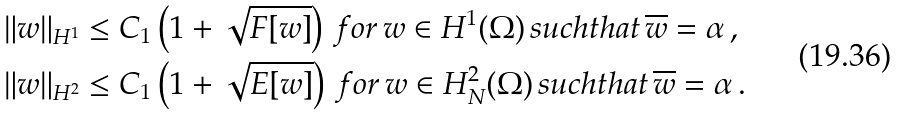Convert formula to latex. <formula><loc_0><loc_0><loc_500><loc_500>\| w \| _ { H ^ { 1 } } & \leq C _ { 1 } \left ( 1 + \sqrt { F [ w ] } \right ) \, f o r \, w \in H ^ { 1 } ( \Omega ) \, s u c h t h a t \, \overline { w } = \alpha \, , \\ \| w \| _ { H ^ { 2 } } & \leq C _ { 1 } \left ( 1 + \sqrt { E [ w ] } \right ) \, f o r \, w \in H _ { N } ^ { 2 } ( \Omega ) \, s u c h t h a t \, \overline { w } = \alpha \, .</formula> 